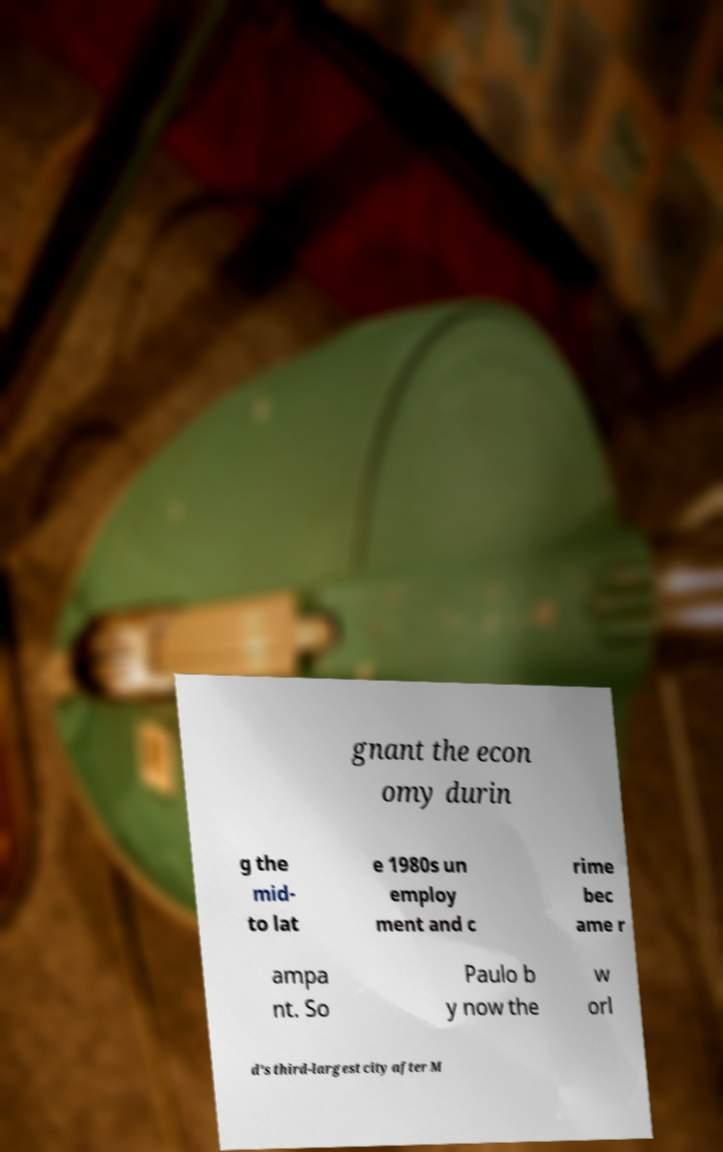There's text embedded in this image that I need extracted. Can you transcribe it verbatim? gnant the econ omy durin g the mid- to lat e 1980s un employ ment and c rime bec ame r ampa nt. So Paulo b y now the w orl d's third-largest city after M 